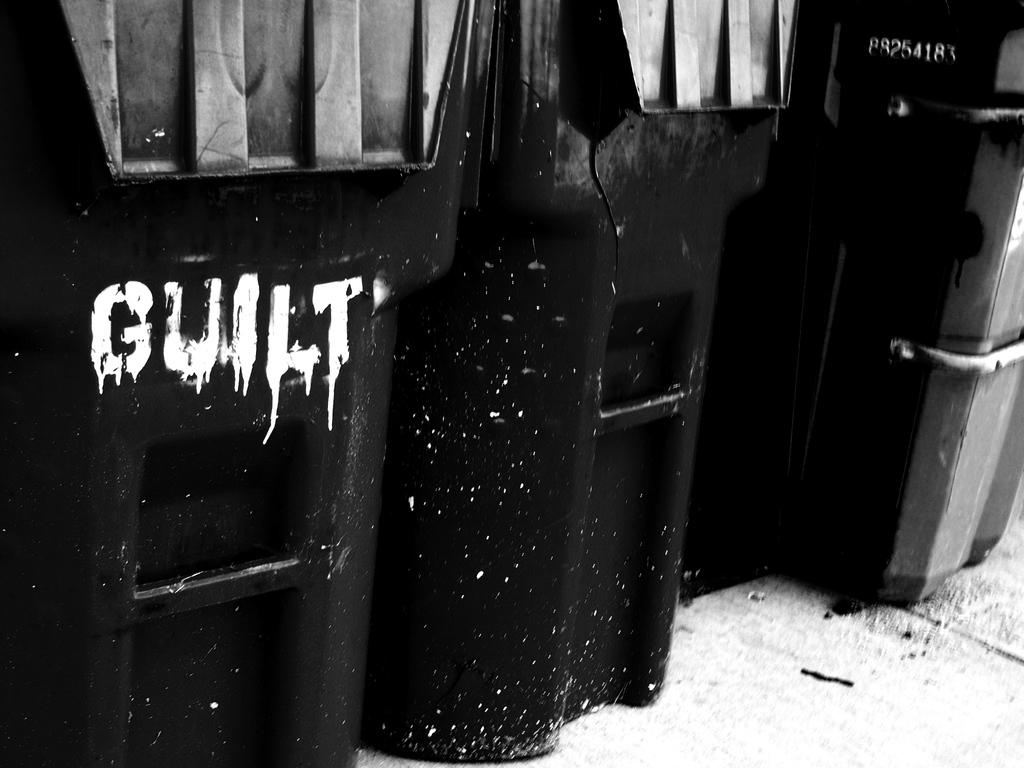<image>
Offer a succinct explanation of the picture presented. Black trash cans are lined up, one of which has GUILT scrawled on it. 